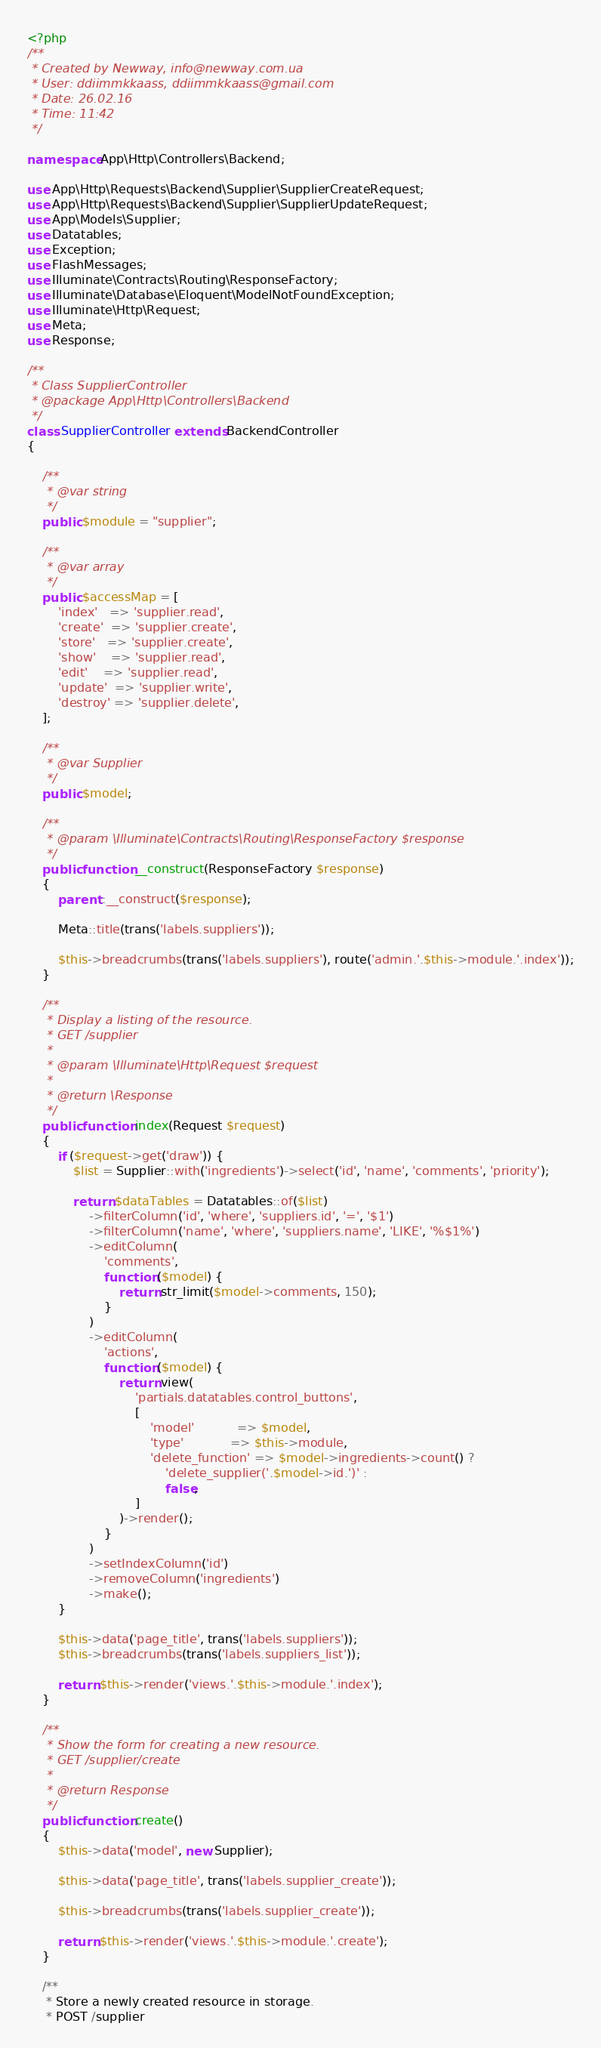Convert code to text. <code><loc_0><loc_0><loc_500><loc_500><_PHP_><?php
/**
 * Created by Newway, info@newway.com.ua
 * User: ddiimmkkaass, ddiimmkkaass@gmail.com
 * Date: 26.02.16
 * Time: 11:42
 */

namespace App\Http\Controllers\Backend;

use App\Http\Requests\Backend\Supplier\SupplierCreateRequest;
use App\Http\Requests\Backend\Supplier\SupplierUpdateRequest;
use App\Models\Supplier;
use Datatables;
use Exception;
use FlashMessages;
use Illuminate\Contracts\Routing\ResponseFactory;
use Illuminate\Database\Eloquent\ModelNotFoundException;
use Illuminate\Http\Request;
use Meta;
use Response;

/**
 * Class SupplierController
 * @package App\Http\Controllers\Backend
 */
class SupplierController extends BackendController
{
    
    /**
     * @var string
     */
    public $module = "supplier";
    
    /**
     * @var array
     */
    public $accessMap = [
        'index'   => 'supplier.read',
        'create'  => 'supplier.create',
        'store'   => 'supplier.create',
        'show'    => 'supplier.read',
        'edit'    => 'supplier.read',
        'update'  => 'supplier.write',
        'destroy' => 'supplier.delete',
    ];
    
    /**
     * @var Supplier
     */
    public $model;
    
    /**
     * @param \Illuminate\Contracts\Routing\ResponseFactory $response
     */
    public function __construct(ResponseFactory $response)
    {
        parent::__construct($response);
        
        Meta::title(trans('labels.suppliers'));
        
        $this->breadcrumbs(trans('labels.suppliers'), route('admin.'.$this->module.'.index'));
    }
    
    /**
     * Display a listing of the resource.
     * GET /supplier
     *
     * @param \Illuminate\Http\Request $request
     *
     * @return \Response
     */
    public function index(Request $request)
    {
        if ($request->get('draw')) {
            $list = Supplier::with('ingredients')->select('id', 'name', 'comments', 'priority');
            
            return $dataTables = Datatables::of($list)
                ->filterColumn('id', 'where', 'suppliers.id', '=', '$1')
                ->filterColumn('name', 'where', 'suppliers.name', 'LIKE', '%$1%')
                ->editColumn(
                    'comments',
                    function ($model) {
                        return str_limit($model->comments, 150);
                    }
                )
                ->editColumn(
                    'actions',
                    function ($model) {
                        return view(
                            'partials.datatables.control_buttons',
                            [
                                'model'           => $model,
                                'type'            => $this->module,
                                'delete_function' => $model->ingredients->count() ?
                                    'delete_supplier('.$model->id.')' :
                                    false,
                            ]
                        )->render();
                    }
                )
                ->setIndexColumn('id')
                ->removeColumn('ingredients')
                ->make();
        }
        
        $this->data('page_title', trans('labels.suppliers'));
        $this->breadcrumbs(trans('labels.suppliers_list'));
        
        return $this->render('views.'.$this->module.'.index');
    }
    
    /**
     * Show the form for creating a new resource.
     * GET /supplier/create
     *
     * @return Response
     */
    public function create()
    {
        $this->data('model', new Supplier);
        
        $this->data('page_title', trans('labels.supplier_create'));
        
        $this->breadcrumbs(trans('labels.supplier_create'));
        
        return $this->render('views.'.$this->module.'.create');
    }
    
    /**
     * Store a newly created resource in storage.
     * POST /supplier</code> 